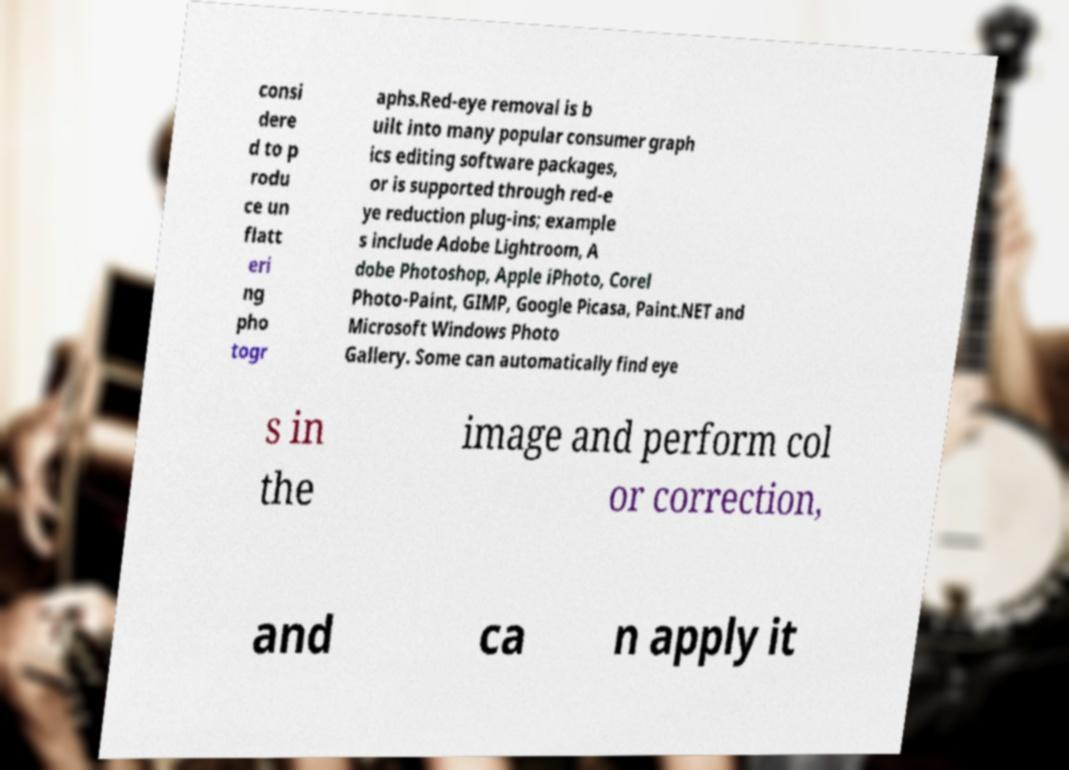Could you extract and type out the text from this image? consi dere d to p rodu ce un flatt eri ng pho togr aphs.Red-eye removal is b uilt into many popular consumer graph ics editing software packages, or is supported through red-e ye reduction plug-ins; example s include Adobe Lightroom, A dobe Photoshop, Apple iPhoto, Corel Photo-Paint, GIMP, Google Picasa, Paint.NET and Microsoft Windows Photo Gallery. Some can automatically find eye s in the image and perform col or correction, and ca n apply it 